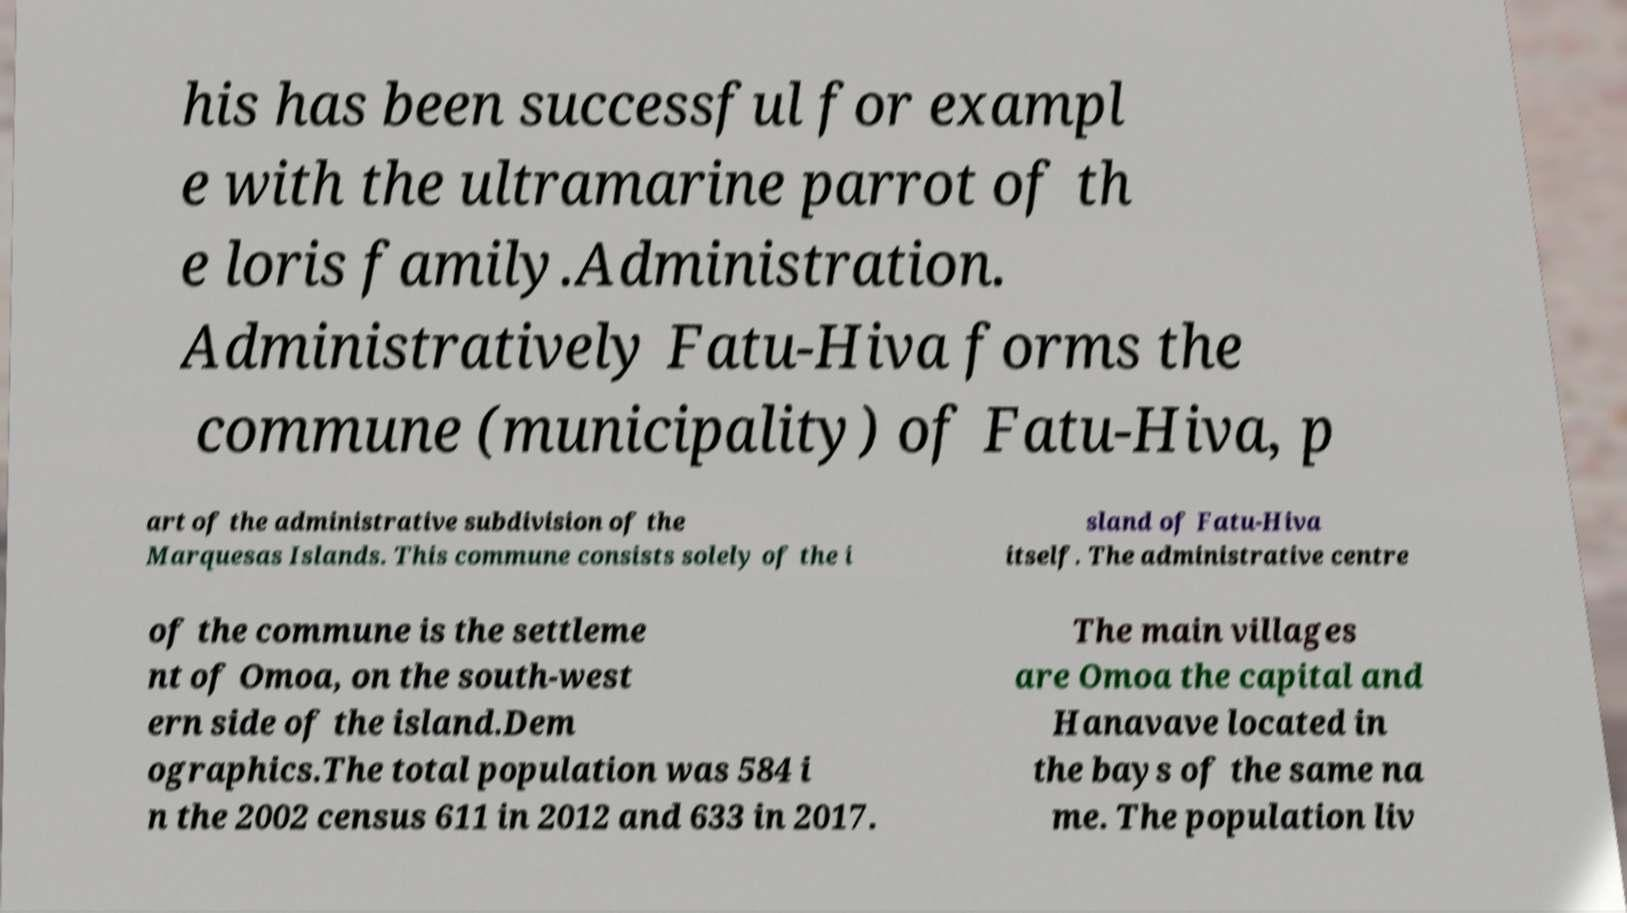Could you extract and type out the text from this image? his has been successful for exampl e with the ultramarine parrot of th e loris family.Administration. Administratively Fatu-Hiva forms the commune (municipality) of Fatu-Hiva, p art of the administrative subdivision of the Marquesas Islands. This commune consists solely of the i sland of Fatu-Hiva itself. The administrative centre of the commune is the settleme nt of Omoa, on the south-west ern side of the island.Dem ographics.The total population was 584 i n the 2002 census 611 in 2012 and 633 in 2017. The main villages are Omoa the capital and Hanavave located in the bays of the same na me. The population liv 